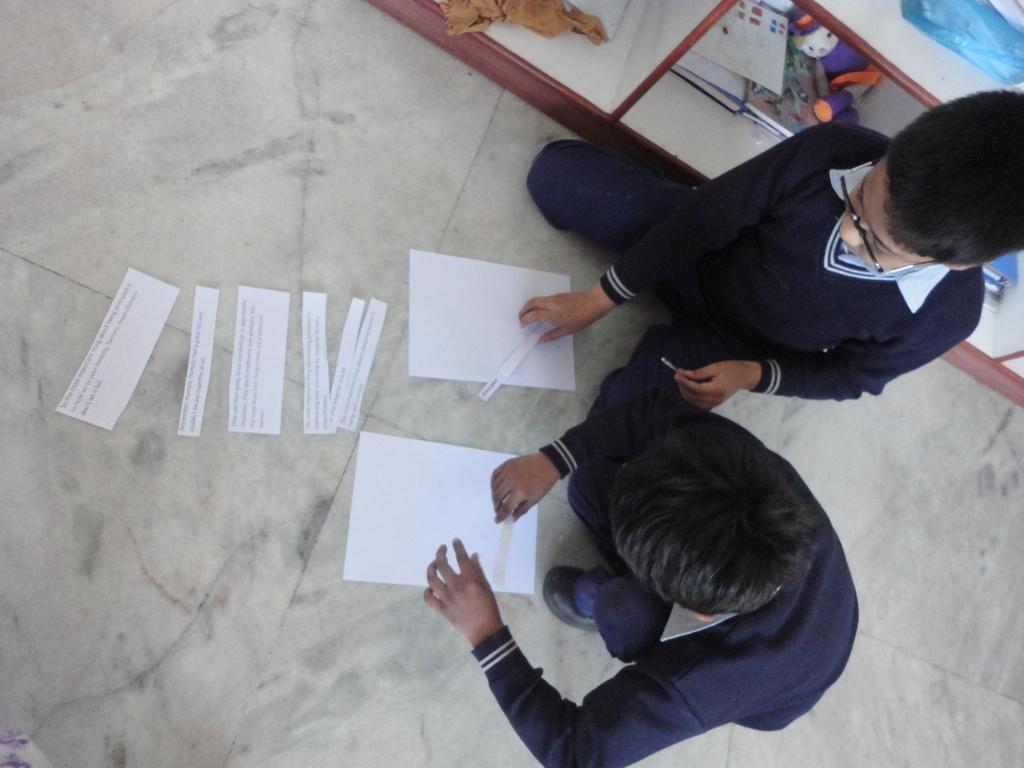Describe this image in one or two sentences. In this picture I can see two boys are touching the papers, they are wearing the sweaters. On the right side there are books and other things on the shelves. 